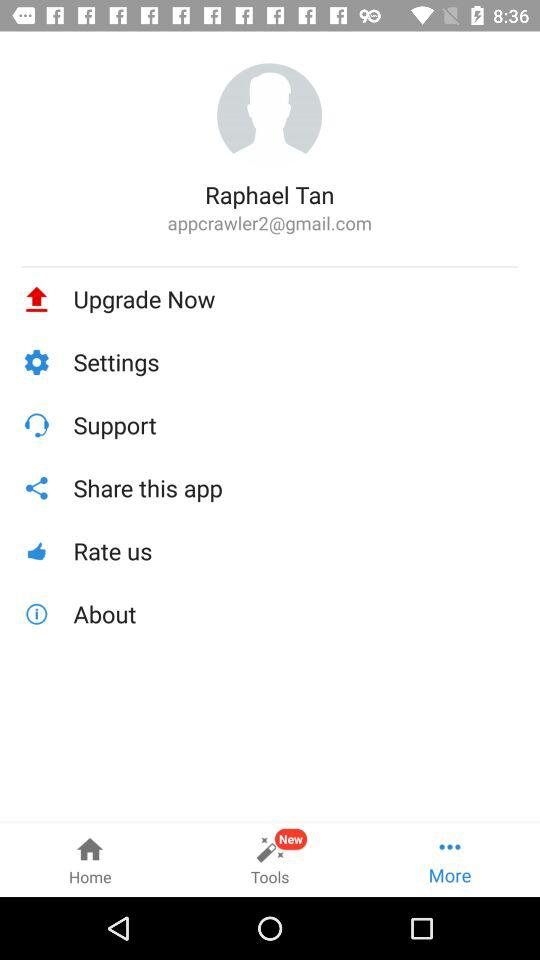What is the user's name? The user's name is "Raphael Tan". 